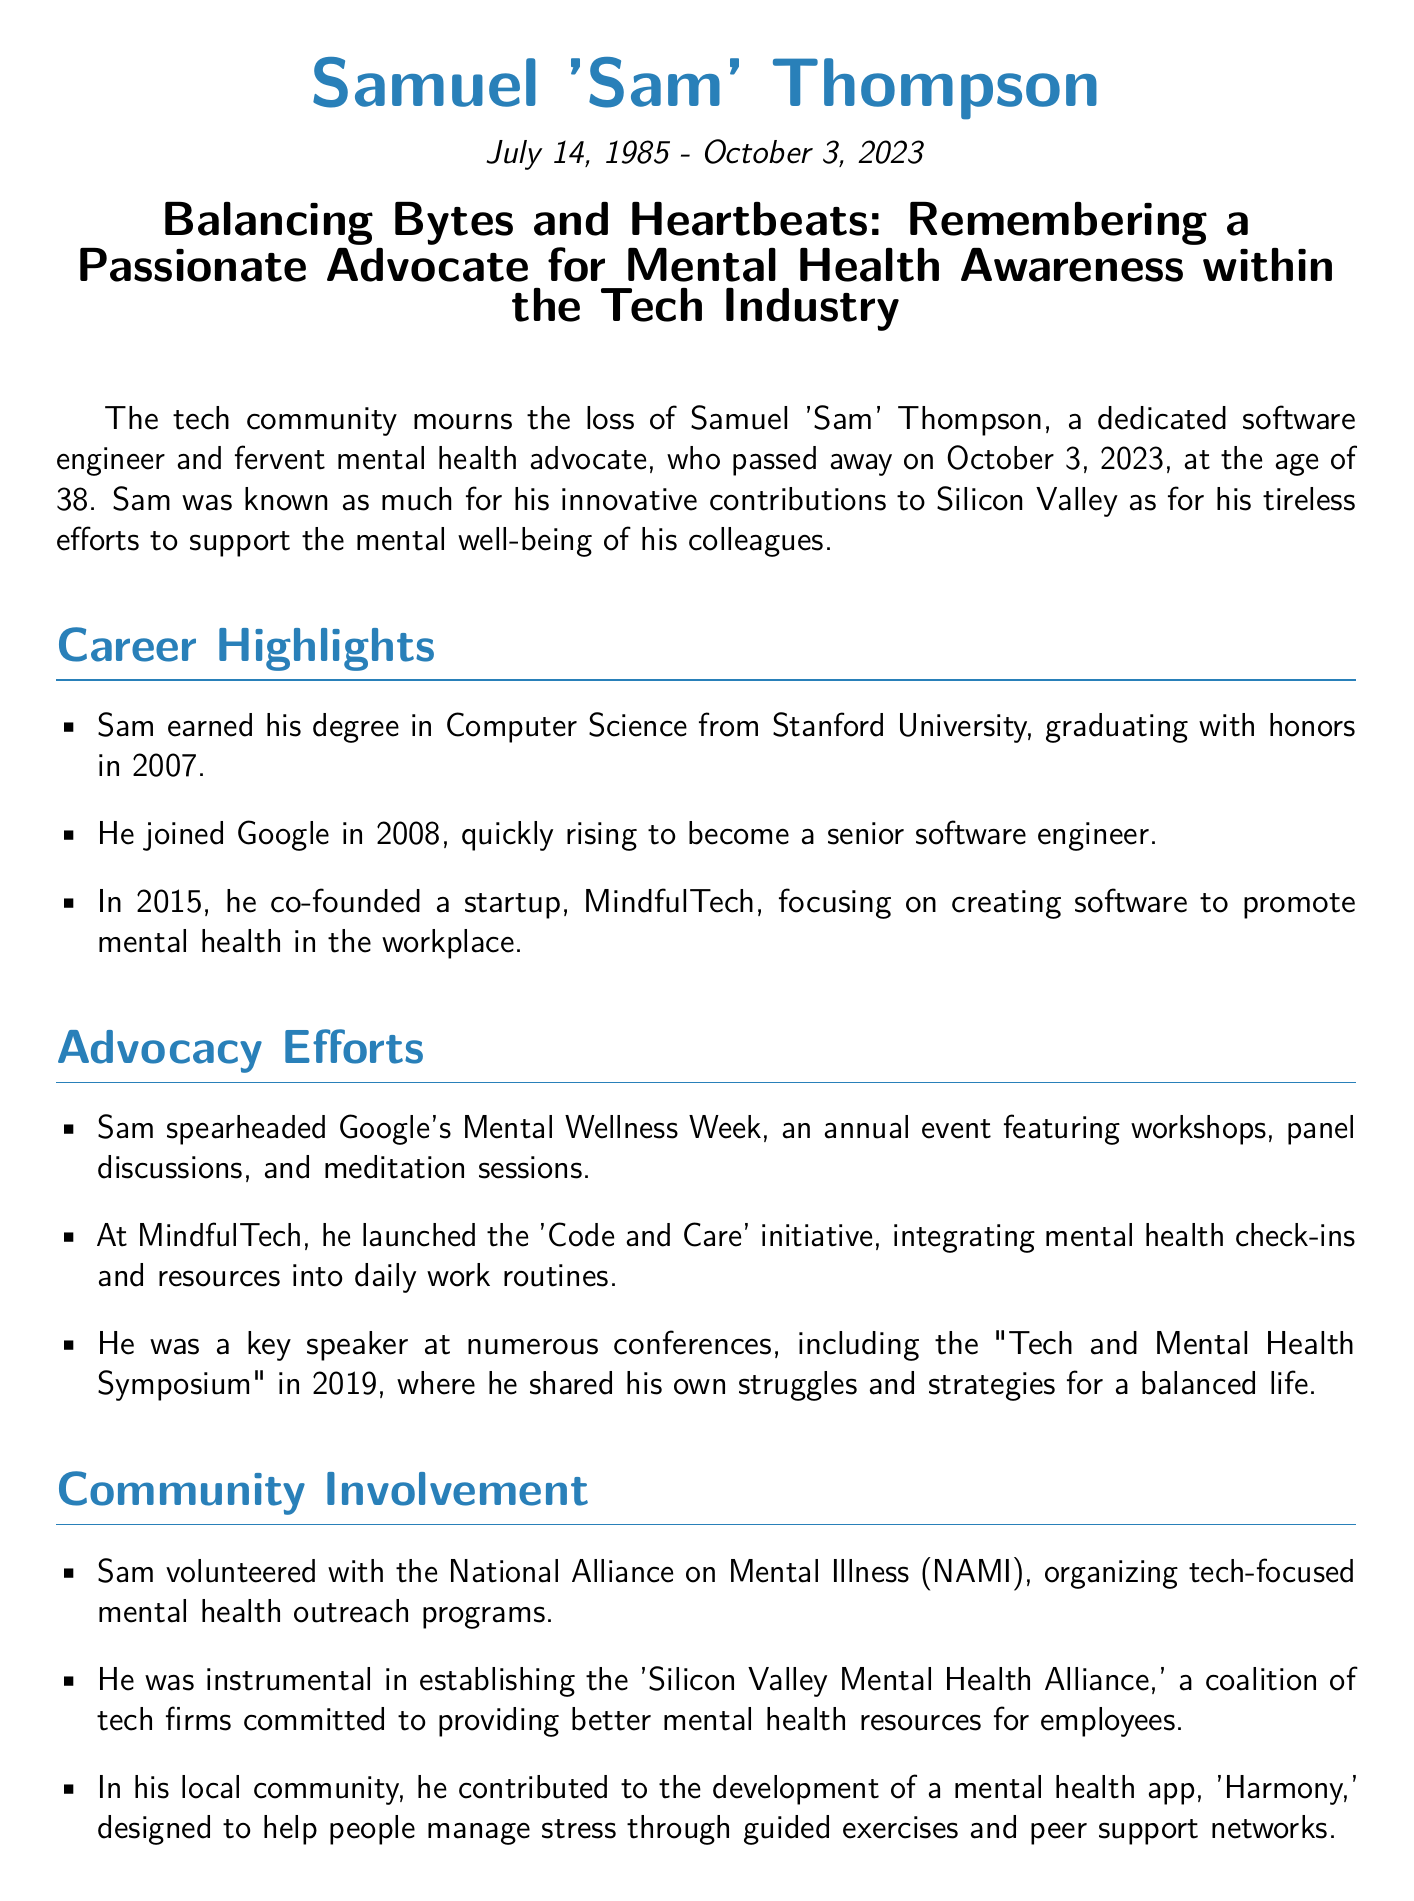What was Samuel 'Sam' Thompson's birth date? The document states that Sam was born on July 14, 1985.
Answer: July 14, 1985 What company did Sam co-found? The obituary highlights that he co-founded MindfulTech.
Answer: MindfulTech What initiative did Sam launch at MindfulTech? The initiative he launched is named 'Code and Care.'
Answer: Code and Care How old was Sam when he passed away? The document mentions that he passed away at the age of 38.
Answer: 38 What event did Sam spearhead at Google? He spearheaded Google's Mental Wellness Week.
Answer: Mental Wellness Week What community organization did Sam volunteer with? The document states he volunteered with the National Alliance on Mental Illness (NAMI).
Answer: National Alliance on Mental Illness (NAMI) What year did Sam speak at the "Tech and Mental Health Symposium"? The obituary notes that he was a key speaker in 2019.
Answer: 2019 Who is quoted as saying Sam was the heart of their mission? Jessica Wang is quoted regarding Sam's impact on their mission.
Answer: Jessica Wang What is the name of the mental health app Sam contributed to? He contributed to the development of the app called 'Harmony.'
Answer: Harmony 